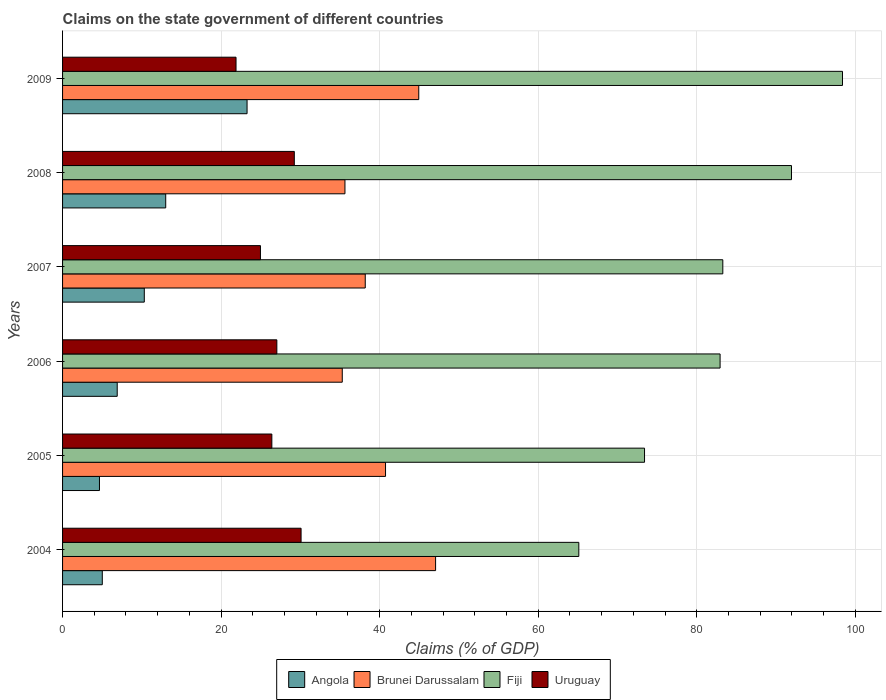How many different coloured bars are there?
Your answer should be compact. 4. How many groups of bars are there?
Make the answer very short. 6. How many bars are there on the 4th tick from the top?
Offer a terse response. 4. How many bars are there on the 5th tick from the bottom?
Offer a terse response. 4. What is the percentage of GDP claimed on the state government in Uruguay in 2004?
Provide a short and direct response. 30.08. Across all years, what is the maximum percentage of GDP claimed on the state government in Fiji?
Your answer should be compact. 98.38. Across all years, what is the minimum percentage of GDP claimed on the state government in Uruguay?
Offer a terse response. 21.88. In which year was the percentage of GDP claimed on the state government in Uruguay minimum?
Offer a terse response. 2009. What is the total percentage of GDP claimed on the state government in Brunei Darussalam in the graph?
Your answer should be compact. 241.79. What is the difference between the percentage of GDP claimed on the state government in Angola in 2006 and that in 2007?
Your answer should be compact. -3.42. What is the difference between the percentage of GDP claimed on the state government in Brunei Darussalam in 2009 and the percentage of GDP claimed on the state government in Fiji in 2007?
Keep it short and to the point. -38.35. What is the average percentage of GDP claimed on the state government in Uruguay per year?
Offer a very short reply. 26.6. In the year 2008, what is the difference between the percentage of GDP claimed on the state government in Fiji and percentage of GDP claimed on the state government in Uruguay?
Provide a succinct answer. 62.71. In how many years, is the percentage of GDP claimed on the state government in Angola greater than 4 %?
Offer a terse response. 6. What is the ratio of the percentage of GDP claimed on the state government in Fiji in 2006 to that in 2009?
Provide a succinct answer. 0.84. Is the percentage of GDP claimed on the state government in Brunei Darussalam in 2004 less than that in 2005?
Ensure brevity in your answer.  No. What is the difference between the highest and the second highest percentage of GDP claimed on the state government in Uruguay?
Make the answer very short. 0.85. What is the difference between the highest and the lowest percentage of GDP claimed on the state government in Brunei Darussalam?
Keep it short and to the point. 11.77. In how many years, is the percentage of GDP claimed on the state government in Uruguay greater than the average percentage of GDP claimed on the state government in Uruguay taken over all years?
Ensure brevity in your answer.  3. Is the sum of the percentage of GDP claimed on the state government in Fiji in 2006 and 2007 greater than the maximum percentage of GDP claimed on the state government in Brunei Darussalam across all years?
Keep it short and to the point. Yes. Is it the case that in every year, the sum of the percentage of GDP claimed on the state government in Brunei Darussalam and percentage of GDP claimed on the state government in Uruguay is greater than the sum of percentage of GDP claimed on the state government in Fiji and percentage of GDP claimed on the state government in Angola?
Your answer should be very brief. Yes. What does the 4th bar from the top in 2007 represents?
Offer a terse response. Angola. What does the 2nd bar from the bottom in 2008 represents?
Offer a terse response. Brunei Darussalam. Is it the case that in every year, the sum of the percentage of GDP claimed on the state government in Angola and percentage of GDP claimed on the state government in Fiji is greater than the percentage of GDP claimed on the state government in Brunei Darussalam?
Make the answer very short. Yes. How many bars are there?
Keep it short and to the point. 24. Are the values on the major ticks of X-axis written in scientific E-notation?
Your answer should be very brief. No. Does the graph contain grids?
Your answer should be compact. Yes. Where does the legend appear in the graph?
Provide a short and direct response. Bottom center. How many legend labels are there?
Provide a short and direct response. 4. How are the legend labels stacked?
Your answer should be compact. Horizontal. What is the title of the graph?
Offer a very short reply. Claims on the state government of different countries. Does "Turkmenistan" appear as one of the legend labels in the graph?
Keep it short and to the point. No. What is the label or title of the X-axis?
Your answer should be very brief. Claims (% of GDP). What is the label or title of the Y-axis?
Provide a short and direct response. Years. What is the Claims (% of GDP) in Angola in 2004?
Your answer should be very brief. 5.01. What is the Claims (% of GDP) of Brunei Darussalam in 2004?
Provide a succinct answer. 47.05. What is the Claims (% of GDP) in Fiji in 2004?
Ensure brevity in your answer.  65.12. What is the Claims (% of GDP) in Uruguay in 2004?
Your response must be concise. 30.08. What is the Claims (% of GDP) of Angola in 2005?
Your answer should be compact. 4.66. What is the Claims (% of GDP) in Brunei Darussalam in 2005?
Your answer should be very brief. 40.74. What is the Claims (% of GDP) of Fiji in 2005?
Offer a terse response. 73.4. What is the Claims (% of GDP) in Uruguay in 2005?
Your answer should be compact. 26.4. What is the Claims (% of GDP) in Angola in 2006?
Keep it short and to the point. 6.89. What is the Claims (% of GDP) of Brunei Darussalam in 2006?
Offer a terse response. 35.28. What is the Claims (% of GDP) of Fiji in 2006?
Provide a short and direct response. 82.94. What is the Claims (% of GDP) in Uruguay in 2006?
Offer a terse response. 27.03. What is the Claims (% of GDP) of Angola in 2007?
Offer a terse response. 10.31. What is the Claims (% of GDP) of Brunei Darussalam in 2007?
Ensure brevity in your answer.  38.18. What is the Claims (% of GDP) of Fiji in 2007?
Provide a succinct answer. 83.28. What is the Claims (% of GDP) of Uruguay in 2007?
Your response must be concise. 24.96. What is the Claims (% of GDP) in Angola in 2008?
Offer a very short reply. 13.01. What is the Claims (% of GDP) in Brunei Darussalam in 2008?
Your response must be concise. 35.62. What is the Claims (% of GDP) of Fiji in 2008?
Give a very brief answer. 91.94. What is the Claims (% of GDP) in Uruguay in 2008?
Provide a succinct answer. 29.23. What is the Claims (% of GDP) of Angola in 2009?
Give a very brief answer. 23.27. What is the Claims (% of GDP) of Brunei Darussalam in 2009?
Make the answer very short. 44.93. What is the Claims (% of GDP) of Fiji in 2009?
Provide a short and direct response. 98.38. What is the Claims (% of GDP) in Uruguay in 2009?
Ensure brevity in your answer.  21.88. Across all years, what is the maximum Claims (% of GDP) in Angola?
Offer a terse response. 23.27. Across all years, what is the maximum Claims (% of GDP) of Brunei Darussalam?
Your answer should be very brief. 47.05. Across all years, what is the maximum Claims (% of GDP) in Fiji?
Your answer should be compact. 98.38. Across all years, what is the maximum Claims (% of GDP) of Uruguay?
Your answer should be compact. 30.08. Across all years, what is the minimum Claims (% of GDP) in Angola?
Provide a succinct answer. 4.66. Across all years, what is the minimum Claims (% of GDP) of Brunei Darussalam?
Your answer should be compact. 35.28. Across all years, what is the minimum Claims (% of GDP) of Fiji?
Your response must be concise. 65.12. Across all years, what is the minimum Claims (% of GDP) of Uruguay?
Your answer should be very brief. 21.88. What is the total Claims (% of GDP) of Angola in the graph?
Ensure brevity in your answer.  63.15. What is the total Claims (% of GDP) of Brunei Darussalam in the graph?
Your answer should be compact. 241.79. What is the total Claims (% of GDP) in Fiji in the graph?
Make the answer very short. 495.05. What is the total Claims (% of GDP) of Uruguay in the graph?
Ensure brevity in your answer.  159.58. What is the difference between the Claims (% of GDP) in Angola in 2004 and that in 2005?
Your answer should be compact. 0.36. What is the difference between the Claims (% of GDP) in Brunei Darussalam in 2004 and that in 2005?
Your answer should be very brief. 6.31. What is the difference between the Claims (% of GDP) of Fiji in 2004 and that in 2005?
Provide a short and direct response. -8.29. What is the difference between the Claims (% of GDP) in Uruguay in 2004 and that in 2005?
Give a very brief answer. 3.69. What is the difference between the Claims (% of GDP) of Angola in 2004 and that in 2006?
Keep it short and to the point. -1.88. What is the difference between the Claims (% of GDP) of Brunei Darussalam in 2004 and that in 2006?
Keep it short and to the point. 11.77. What is the difference between the Claims (% of GDP) of Fiji in 2004 and that in 2006?
Provide a succinct answer. -17.82. What is the difference between the Claims (% of GDP) of Uruguay in 2004 and that in 2006?
Your answer should be very brief. 3.06. What is the difference between the Claims (% of GDP) in Angola in 2004 and that in 2007?
Provide a short and direct response. -5.3. What is the difference between the Claims (% of GDP) of Brunei Darussalam in 2004 and that in 2007?
Your answer should be compact. 8.87. What is the difference between the Claims (% of GDP) of Fiji in 2004 and that in 2007?
Ensure brevity in your answer.  -18.16. What is the difference between the Claims (% of GDP) of Uruguay in 2004 and that in 2007?
Your answer should be very brief. 5.12. What is the difference between the Claims (% of GDP) in Angola in 2004 and that in 2008?
Offer a terse response. -8. What is the difference between the Claims (% of GDP) of Brunei Darussalam in 2004 and that in 2008?
Make the answer very short. 11.43. What is the difference between the Claims (% of GDP) in Fiji in 2004 and that in 2008?
Your answer should be very brief. -26.83. What is the difference between the Claims (% of GDP) of Uruguay in 2004 and that in 2008?
Your answer should be very brief. 0.85. What is the difference between the Claims (% of GDP) in Angola in 2004 and that in 2009?
Provide a short and direct response. -18.26. What is the difference between the Claims (% of GDP) in Brunei Darussalam in 2004 and that in 2009?
Offer a terse response. 2.12. What is the difference between the Claims (% of GDP) of Fiji in 2004 and that in 2009?
Provide a succinct answer. -33.26. What is the difference between the Claims (% of GDP) in Uruguay in 2004 and that in 2009?
Offer a terse response. 8.2. What is the difference between the Claims (% of GDP) in Angola in 2005 and that in 2006?
Ensure brevity in your answer.  -2.24. What is the difference between the Claims (% of GDP) in Brunei Darussalam in 2005 and that in 2006?
Give a very brief answer. 5.46. What is the difference between the Claims (% of GDP) of Fiji in 2005 and that in 2006?
Your answer should be very brief. -9.53. What is the difference between the Claims (% of GDP) in Uruguay in 2005 and that in 2006?
Your answer should be very brief. -0.63. What is the difference between the Claims (% of GDP) in Angola in 2005 and that in 2007?
Make the answer very short. -5.65. What is the difference between the Claims (% of GDP) in Brunei Darussalam in 2005 and that in 2007?
Your answer should be very brief. 2.56. What is the difference between the Claims (% of GDP) in Fiji in 2005 and that in 2007?
Give a very brief answer. -9.87. What is the difference between the Claims (% of GDP) of Uruguay in 2005 and that in 2007?
Provide a short and direct response. 1.44. What is the difference between the Claims (% of GDP) of Angola in 2005 and that in 2008?
Offer a terse response. -8.36. What is the difference between the Claims (% of GDP) in Brunei Darussalam in 2005 and that in 2008?
Your answer should be very brief. 5.12. What is the difference between the Claims (% of GDP) in Fiji in 2005 and that in 2008?
Give a very brief answer. -18.54. What is the difference between the Claims (% of GDP) of Uruguay in 2005 and that in 2008?
Offer a very short reply. -2.83. What is the difference between the Claims (% of GDP) of Angola in 2005 and that in 2009?
Make the answer very short. -18.62. What is the difference between the Claims (% of GDP) in Brunei Darussalam in 2005 and that in 2009?
Provide a succinct answer. -4.19. What is the difference between the Claims (% of GDP) of Fiji in 2005 and that in 2009?
Keep it short and to the point. -24.97. What is the difference between the Claims (% of GDP) in Uruguay in 2005 and that in 2009?
Provide a succinct answer. 4.52. What is the difference between the Claims (% of GDP) of Angola in 2006 and that in 2007?
Ensure brevity in your answer.  -3.42. What is the difference between the Claims (% of GDP) of Fiji in 2006 and that in 2007?
Offer a very short reply. -0.34. What is the difference between the Claims (% of GDP) in Uruguay in 2006 and that in 2007?
Offer a very short reply. 2.07. What is the difference between the Claims (% of GDP) in Angola in 2006 and that in 2008?
Provide a short and direct response. -6.12. What is the difference between the Claims (% of GDP) in Brunei Darussalam in 2006 and that in 2008?
Your answer should be very brief. -0.34. What is the difference between the Claims (% of GDP) in Fiji in 2006 and that in 2008?
Provide a succinct answer. -9. What is the difference between the Claims (% of GDP) of Uruguay in 2006 and that in 2008?
Give a very brief answer. -2.2. What is the difference between the Claims (% of GDP) in Angola in 2006 and that in 2009?
Keep it short and to the point. -16.38. What is the difference between the Claims (% of GDP) of Brunei Darussalam in 2006 and that in 2009?
Ensure brevity in your answer.  -9.65. What is the difference between the Claims (% of GDP) in Fiji in 2006 and that in 2009?
Offer a very short reply. -15.44. What is the difference between the Claims (% of GDP) in Uruguay in 2006 and that in 2009?
Provide a short and direct response. 5.15. What is the difference between the Claims (% of GDP) of Angola in 2007 and that in 2008?
Give a very brief answer. -2.7. What is the difference between the Claims (% of GDP) in Brunei Darussalam in 2007 and that in 2008?
Offer a very short reply. 2.56. What is the difference between the Claims (% of GDP) in Fiji in 2007 and that in 2008?
Give a very brief answer. -8.66. What is the difference between the Claims (% of GDP) of Uruguay in 2007 and that in 2008?
Provide a succinct answer. -4.27. What is the difference between the Claims (% of GDP) in Angola in 2007 and that in 2009?
Your answer should be compact. -12.96. What is the difference between the Claims (% of GDP) in Brunei Darussalam in 2007 and that in 2009?
Offer a very short reply. -6.75. What is the difference between the Claims (% of GDP) in Fiji in 2007 and that in 2009?
Ensure brevity in your answer.  -15.1. What is the difference between the Claims (% of GDP) in Uruguay in 2007 and that in 2009?
Give a very brief answer. 3.08. What is the difference between the Claims (% of GDP) in Angola in 2008 and that in 2009?
Make the answer very short. -10.26. What is the difference between the Claims (% of GDP) in Brunei Darussalam in 2008 and that in 2009?
Make the answer very short. -9.31. What is the difference between the Claims (% of GDP) in Fiji in 2008 and that in 2009?
Keep it short and to the point. -6.43. What is the difference between the Claims (% of GDP) in Uruguay in 2008 and that in 2009?
Offer a very short reply. 7.35. What is the difference between the Claims (% of GDP) in Angola in 2004 and the Claims (% of GDP) in Brunei Darussalam in 2005?
Make the answer very short. -35.73. What is the difference between the Claims (% of GDP) in Angola in 2004 and the Claims (% of GDP) in Fiji in 2005?
Your answer should be compact. -68.39. What is the difference between the Claims (% of GDP) of Angola in 2004 and the Claims (% of GDP) of Uruguay in 2005?
Offer a very short reply. -21.39. What is the difference between the Claims (% of GDP) of Brunei Darussalam in 2004 and the Claims (% of GDP) of Fiji in 2005?
Your answer should be compact. -26.35. What is the difference between the Claims (% of GDP) in Brunei Darussalam in 2004 and the Claims (% of GDP) in Uruguay in 2005?
Ensure brevity in your answer.  20.65. What is the difference between the Claims (% of GDP) of Fiji in 2004 and the Claims (% of GDP) of Uruguay in 2005?
Offer a very short reply. 38.72. What is the difference between the Claims (% of GDP) in Angola in 2004 and the Claims (% of GDP) in Brunei Darussalam in 2006?
Your answer should be very brief. -30.27. What is the difference between the Claims (% of GDP) of Angola in 2004 and the Claims (% of GDP) of Fiji in 2006?
Offer a very short reply. -77.92. What is the difference between the Claims (% of GDP) in Angola in 2004 and the Claims (% of GDP) in Uruguay in 2006?
Your response must be concise. -22.02. What is the difference between the Claims (% of GDP) in Brunei Darussalam in 2004 and the Claims (% of GDP) in Fiji in 2006?
Offer a terse response. -35.89. What is the difference between the Claims (% of GDP) in Brunei Darussalam in 2004 and the Claims (% of GDP) in Uruguay in 2006?
Offer a terse response. 20.02. What is the difference between the Claims (% of GDP) in Fiji in 2004 and the Claims (% of GDP) in Uruguay in 2006?
Offer a terse response. 38.09. What is the difference between the Claims (% of GDP) in Angola in 2004 and the Claims (% of GDP) in Brunei Darussalam in 2007?
Provide a short and direct response. -33.17. What is the difference between the Claims (% of GDP) of Angola in 2004 and the Claims (% of GDP) of Fiji in 2007?
Make the answer very short. -78.27. What is the difference between the Claims (% of GDP) in Angola in 2004 and the Claims (% of GDP) in Uruguay in 2007?
Offer a terse response. -19.95. What is the difference between the Claims (% of GDP) of Brunei Darussalam in 2004 and the Claims (% of GDP) of Fiji in 2007?
Offer a very short reply. -36.23. What is the difference between the Claims (% of GDP) of Brunei Darussalam in 2004 and the Claims (% of GDP) of Uruguay in 2007?
Provide a short and direct response. 22.09. What is the difference between the Claims (% of GDP) in Fiji in 2004 and the Claims (% of GDP) in Uruguay in 2007?
Provide a short and direct response. 40.16. What is the difference between the Claims (% of GDP) in Angola in 2004 and the Claims (% of GDP) in Brunei Darussalam in 2008?
Keep it short and to the point. -30.61. What is the difference between the Claims (% of GDP) in Angola in 2004 and the Claims (% of GDP) in Fiji in 2008?
Your answer should be compact. -86.93. What is the difference between the Claims (% of GDP) of Angola in 2004 and the Claims (% of GDP) of Uruguay in 2008?
Provide a succinct answer. -24.22. What is the difference between the Claims (% of GDP) of Brunei Darussalam in 2004 and the Claims (% of GDP) of Fiji in 2008?
Offer a very short reply. -44.89. What is the difference between the Claims (% of GDP) of Brunei Darussalam in 2004 and the Claims (% of GDP) of Uruguay in 2008?
Keep it short and to the point. 17.82. What is the difference between the Claims (% of GDP) of Fiji in 2004 and the Claims (% of GDP) of Uruguay in 2008?
Make the answer very short. 35.89. What is the difference between the Claims (% of GDP) in Angola in 2004 and the Claims (% of GDP) in Brunei Darussalam in 2009?
Keep it short and to the point. -39.92. What is the difference between the Claims (% of GDP) in Angola in 2004 and the Claims (% of GDP) in Fiji in 2009?
Offer a terse response. -93.36. What is the difference between the Claims (% of GDP) in Angola in 2004 and the Claims (% of GDP) in Uruguay in 2009?
Your answer should be very brief. -16.87. What is the difference between the Claims (% of GDP) of Brunei Darussalam in 2004 and the Claims (% of GDP) of Fiji in 2009?
Your answer should be compact. -51.32. What is the difference between the Claims (% of GDP) of Brunei Darussalam in 2004 and the Claims (% of GDP) of Uruguay in 2009?
Offer a terse response. 25.17. What is the difference between the Claims (% of GDP) of Fiji in 2004 and the Claims (% of GDP) of Uruguay in 2009?
Ensure brevity in your answer.  43.24. What is the difference between the Claims (% of GDP) of Angola in 2005 and the Claims (% of GDP) of Brunei Darussalam in 2006?
Your response must be concise. -30.62. What is the difference between the Claims (% of GDP) in Angola in 2005 and the Claims (% of GDP) in Fiji in 2006?
Provide a short and direct response. -78.28. What is the difference between the Claims (% of GDP) of Angola in 2005 and the Claims (% of GDP) of Uruguay in 2006?
Make the answer very short. -22.37. What is the difference between the Claims (% of GDP) in Brunei Darussalam in 2005 and the Claims (% of GDP) in Fiji in 2006?
Provide a short and direct response. -42.2. What is the difference between the Claims (% of GDP) in Brunei Darussalam in 2005 and the Claims (% of GDP) in Uruguay in 2006?
Your response must be concise. 13.71. What is the difference between the Claims (% of GDP) in Fiji in 2005 and the Claims (% of GDP) in Uruguay in 2006?
Provide a short and direct response. 46.38. What is the difference between the Claims (% of GDP) in Angola in 2005 and the Claims (% of GDP) in Brunei Darussalam in 2007?
Your answer should be very brief. -33.52. What is the difference between the Claims (% of GDP) in Angola in 2005 and the Claims (% of GDP) in Fiji in 2007?
Make the answer very short. -78.62. What is the difference between the Claims (% of GDP) of Angola in 2005 and the Claims (% of GDP) of Uruguay in 2007?
Provide a short and direct response. -20.3. What is the difference between the Claims (% of GDP) in Brunei Darussalam in 2005 and the Claims (% of GDP) in Fiji in 2007?
Provide a short and direct response. -42.54. What is the difference between the Claims (% of GDP) of Brunei Darussalam in 2005 and the Claims (% of GDP) of Uruguay in 2007?
Offer a terse response. 15.78. What is the difference between the Claims (% of GDP) in Fiji in 2005 and the Claims (% of GDP) in Uruguay in 2007?
Your answer should be compact. 48.45. What is the difference between the Claims (% of GDP) in Angola in 2005 and the Claims (% of GDP) in Brunei Darussalam in 2008?
Your response must be concise. -30.96. What is the difference between the Claims (% of GDP) in Angola in 2005 and the Claims (% of GDP) in Fiji in 2008?
Provide a short and direct response. -87.29. What is the difference between the Claims (% of GDP) in Angola in 2005 and the Claims (% of GDP) in Uruguay in 2008?
Your response must be concise. -24.57. What is the difference between the Claims (% of GDP) in Brunei Darussalam in 2005 and the Claims (% of GDP) in Fiji in 2008?
Provide a short and direct response. -51.2. What is the difference between the Claims (% of GDP) of Brunei Darussalam in 2005 and the Claims (% of GDP) of Uruguay in 2008?
Your answer should be very brief. 11.51. What is the difference between the Claims (% of GDP) in Fiji in 2005 and the Claims (% of GDP) in Uruguay in 2008?
Make the answer very short. 44.17. What is the difference between the Claims (% of GDP) in Angola in 2005 and the Claims (% of GDP) in Brunei Darussalam in 2009?
Your answer should be very brief. -40.27. What is the difference between the Claims (% of GDP) of Angola in 2005 and the Claims (% of GDP) of Fiji in 2009?
Your answer should be very brief. -93.72. What is the difference between the Claims (% of GDP) in Angola in 2005 and the Claims (% of GDP) in Uruguay in 2009?
Provide a succinct answer. -17.22. What is the difference between the Claims (% of GDP) in Brunei Darussalam in 2005 and the Claims (% of GDP) in Fiji in 2009?
Provide a succinct answer. -57.64. What is the difference between the Claims (% of GDP) of Brunei Darussalam in 2005 and the Claims (% of GDP) of Uruguay in 2009?
Ensure brevity in your answer.  18.86. What is the difference between the Claims (% of GDP) in Fiji in 2005 and the Claims (% of GDP) in Uruguay in 2009?
Keep it short and to the point. 51.53. What is the difference between the Claims (% of GDP) in Angola in 2006 and the Claims (% of GDP) in Brunei Darussalam in 2007?
Your answer should be compact. -31.28. What is the difference between the Claims (% of GDP) of Angola in 2006 and the Claims (% of GDP) of Fiji in 2007?
Ensure brevity in your answer.  -76.38. What is the difference between the Claims (% of GDP) of Angola in 2006 and the Claims (% of GDP) of Uruguay in 2007?
Your answer should be very brief. -18.07. What is the difference between the Claims (% of GDP) of Brunei Darussalam in 2006 and the Claims (% of GDP) of Fiji in 2007?
Ensure brevity in your answer.  -48. What is the difference between the Claims (% of GDP) of Brunei Darussalam in 2006 and the Claims (% of GDP) of Uruguay in 2007?
Provide a succinct answer. 10.32. What is the difference between the Claims (% of GDP) in Fiji in 2006 and the Claims (% of GDP) in Uruguay in 2007?
Give a very brief answer. 57.98. What is the difference between the Claims (% of GDP) in Angola in 2006 and the Claims (% of GDP) in Brunei Darussalam in 2008?
Offer a terse response. -28.72. What is the difference between the Claims (% of GDP) in Angola in 2006 and the Claims (% of GDP) in Fiji in 2008?
Provide a short and direct response. -85.05. What is the difference between the Claims (% of GDP) in Angola in 2006 and the Claims (% of GDP) in Uruguay in 2008?
Provide a succinct answer. -22.34. What is the difference between the Claims (% of GDP) in Brunei Darussalam in 2006 and the Claims (% of GDP) in Fiji in 2008?
Provide a short and direct response. -56.66. What is the difference between the Claims (% of GDP) in Brunei Darussalam in 2006 and the Claims (% of GDP) in Uruguay in 2008?
Keep it short and to the point. 6.05. What is the difference between the Claims (% of GDP) of Fiji in 2006 and the Claims (% of GDP) of Uruguay in 2008?
Provide a succinct answer. 53.71. What is the difference between the Claims (% of GDP) of Angola in 2006 and the Claims (% of GDP) of Brunei Darussalam in 2009?
Give a very brief answer. -38.04. What is the difference between the Claims (% of GDP) in Angola in 2006 and the Claims (% of GDP) in Fiji in 2009?
Keep it short and to the point. -91.48. What is the difference between the Claims (% of GDP) of Angola in 2006 and the Claims (% of GDP) of Uruguay in 2009?
Your answer should be very brief. -14.99. What is the difference between the Claims (% of GDP) of Brunei Darussalam in 2006 and the Claims (% of GDP) of Fiji in 2009?
Keep it short and to the point. -63.1. What is the difference between the Claims (% of GDP) in Brunei Darussalam in 2006 and the Claims (% of GDP) in Uruguay in 2009?
Offer a very short reply. 13.4. What is the difference between the Claims (% of GDP) in Fiji in 2006 and the Claims (% of GDP) in Uruguay in 2009?
Provide a succinct answer. 61.06. What is the difference between the Claims (% of GDP) of Angola in 2007 and the Claims (% of GDP) of Brunei Darussalam in 2008?
Keep it short and to the point. -25.31. What is the difference between the Claims (% of GDP) of Angola in 2007 and the Claims (% of GDP) of Fiji in 2008?
Your answer should be very brief. -81.63. What is the difference between the Claims (% of GDP) of Angola in 2007 and the Claims (% of GDP) of Uruguay in 2008?
Give a very brief answer. -18.92. What is the difference between the Claims (% of GDP) of Brunei Darussalam in 2007 and the Claims (% of GDP) of Fiji in 2008?
Your response must be concise. -53.76. What is the difference between the Claims (% of GDP) of Brunei Darussalam in 2007 and the Claims (% of GDP) of Uruguay in 2008?
Your response must be concise. 8.95. What is the difference between the Claims (% of GDP) of Fiji in 2007 and the Claims (% of GDP) of Uruguay in 2008?
Give a very brief answer. 54.05. What is the difference between the Claims (% of GDP) of Angola in 2007 and the Claims (% of GDP) of Brunei Darussalam in 2009?
Make the answer very short. -34.62. What is the difference between the Claims (% of GDP) of Angola in 2007 and the Claims (% of GDP) of Fiji in 2009?
Ensure brevity in your answer.  -88.07. What is the difference between the Claims (% of GDP) in Angola in 2007 and the Claims (% of GDP) in Uruguay in 2009?
Provide a succinct answer. -11.57. What is the difference between the Claims (% of GDP) of Brunei Darussalam in 2007 and the Claims (% of GDP) of Fiji in 2009?
Make the answer very short. -60.2. What is the difference between the Claims (% of GDP) in Brunei Darussalam in 2007 and the Claims (% of GDP) in Uruguay in 2009?
Your response must be concise. 16.3. What is the difference between the Claims (% of GDP) of Fiji in 2007 and the Claims (% of GDP) of Uruguay in 2009?
Make the answer very short. 61.4. What is the difference between the Claims (% of GDP) in Angola in 2008 and the Claims (% of GDP) in Brunei Darussalam in 2009?
Give a very brief answer. -31.92. What is the difference between the Claims (% of GDP) in Angola in 2008 and the Claims (% of GDP) in Fiji in 2009?
Your answer should be very brief. -85.36. What is the difference between the Claims (% of GDP) in Angola in 2008 and the Claims (% of GDP) in Uruguay in 2009?
Ensure brevity in your answer.  -8.87. What is the difference between the Claims (% of GDP) in Brunei Darussalam in 2008 and the Claims (% of GDP) in Fiji in 2009?
Your response must be concise. -62.76. What is the difference between the Claims (% of GDP) of Brunei Darussalam in 2008 and the Claims (% of GDP) of Uruguay in 2009?
Your answer should be very brief. 13.74. What is the difference between the Claims (% of GDP) of Fiji in 2008 and the Claims (% of GDP) of Uruguay in 2009?
Offer a very short reply. 70.06. What is the average Claims (% of GDP) in Angola per year?
Provide a short and direct response. 10.53. What is the average Claims (% of GDP) in Brunei Darussalam per year?
Give a very brief answer. 40.3. What is the average Claims (% of GDP) in Fiji per year?
Provide a short and direct response. 82.51. What is the average Claims (% of GDP) of Uruguay per year?
Ensure brevity in your answer.  26.6. In the year 2004, what is the difference between the Claims (% of GDP) in Angola and Claims (% of GDP) in Brunei Darussalam?
Your response must be concise. -42.04. In the year 2004, what is the difference between the Claims (% of GDP) of Angola and Claims (% of GDP) of Fiji?
Offer a terse response. -60.1. In the year 2004, what is the difference between the Claims (% of GDP) in Angola and Claims (% of GDP) in Uruguay?
Ensure brevity in your answer.  -25.07. In the year 2004, what is the difference between the Claims (% of GDP) of Brunei Darussalam and Claims (% of GDP) of Fiji?
Provide a short and direct response. -18.06. In the year 2004, what is the difference between the Claims (% of GDP) of Brunei Darussalam and Claims (% of GDP) of Uruguay?
Your answer should be very brief. 16.97. In the year 2004, what is the difference between the Claims (% of GDP) of Fiji and Claims (% of GDP) of Uruguay?
Make the answer very short. 35.03. In the year 2005, what is the difference between the Claims (% of GDP) in Angola and Claims (% of GDP) in Brunei Darussalam?
Make the answer very short. -36.08. In the year 2005, what is the difference between the Claims (% of GDP) in Angola and Claims (% of GDP) in Fiji?
Your response must be concise. -68.75. In the year 2005, what is the difference between the Claims (% of GDP) in Angola and Claims (% of GDP) in Uruguay?
Offer a terse response. -21.74. In the year 2005, what is the difference between the Claims (% of GDP) in Brunei Darussalam and Claims (% of GDP) in Fiji?
Provide a succinct answer. -32.67. In the year 2005, what is the difference between the Claims (% of GDP) of Brunei Darussalam and Claims (% of GDP) of Uruguay?
Give a very brief answer. 14.34. In the year 2005, what is the difference between the Claims (% of GDP) in Fiji and Claims (% of GDP) in Uruguay?
Ensure brevity in your answer.  47.01. In the year 2006, what is the difference between the Claims (% of GDP) in Angola and Claims (% of GDP) in Brunei Darussalam?
Your answer should be very brief. -28.38. In the year 2006, what is the difference between the Claims (% of GDP) in Angola and Claims (% of GDP) in Fiji?
Make the answer very short. -76.04. In the year 2006, what is the difference between the Claims (% of GDP) in Angola and Claims (% of GDP) in Uruguay?
Keep it short and to the point. -20.13. In the year 2006, what is the difference between the Claims (% of GDP) in Brunei Darussalam and Claims (% of GDP) in Fiji?
Your answer should be compact. -47.66. In the year 2006, what is the difference between the Claims (% of GDP) in Brunei Darussalam and Claims (% of GDP) in Uruguay?
Your response must be concise. 8.25. In the year 2006, what is the difference between the Claims (% of GDP) of Fiji and Claims (% of GDP) of Uruguay?
Ensure brevity in your answer.  55.91. In the year 2007, what is the difference between the Claims (% of GDP) of Angola and Claims (% of GDP) of Brunei Darussalam?
Give a very brief answer. -27.87. In the year 2007, what is the difference between the Claims (% of GDP) in Angola and Claims (% of GDP) in Fiji?
Offer a very short reply. -72.97. In the year 2007, what is the difference between the Claims (% of GDP) of Angola and Claims (% of GDP) of Uruguay?
Make the answer very short. -14.65. In the year 2007, what is the difference between the Claims (% of GDP) of Brunei Darussalam and Claims (% of GDP) of Fiji?
Offer a terse response. -45.1. In the year 2007, what is the difference between the Claims (% of GDP) of Brunei Darussalam and Claims (% of GDP) of Uruguay?
Keep it short and to the point. 13.22. In the year 2007, what is the difference between the Claims (% of GDP) in Fiji and Claims (% of GDP) in Uruguay?
Your answer should be very brief. 58.32. In the year 2008, what is the difference between the Claims (% of GDP) in Angola and Claims (% of GDP) in Brunei Darussalam?
Give a very brief answer. -22.61. In the year 2008, what is the difference between the Claims (% of GDP) of Angola and Claims (% of GDP) of Fiji?
Ensure brevity in your answer.  -78.93. In the year 2008, what is the difference between the Claims (% of GDP) of Angola and Claims (% of GDP) of Uruguay?
Provide a succinct answer. -16.22. In the year 2008, what is the difference between the Claims (% of GDP) in Brunei Darussalam and Claims (% of GDP) in Fiji?
Keep it short and to the point. -56.32. In the year 2008, what is the difference between the Claims (% of GDP) in Brunei Darussalam and Claims (% of GDP) in Uruguay?
Provide a short and direct response. 6.39. In the year 2008, what is the difference between the Claims (% of GDP) of Fiji and Claims (% of GDP) of Uruguay?
Provide a short and direct response. 62.71. In the year 2009, what is the difference between the Claims (% of GDP) of Angola and Claims (% of GDP) of Brunei Darussalam?
Your answer should be compact. -21.66. In the year 2009, what is the difference between the Claims (% of GDP) in Angola and Claims (% of GDP) in Fiji?
Provide a short and direct response. -75.1. In the year 2009, what is the difference between the Claims (% of GDP) in Angola and Claims (% of GDP) in Uruguay?
Provide a short and direct response. 1.39. In the year 2009, what is the difference between the Claims (% of GDP) of Brunei Darussalam and Claims (% of GDP) of Fiji?
Make the answer very short. -53.45. In the year 2009, what is the difference between the Claims (% of GDP) of Brunei Darussalam and Claims (% of GDP) of Uruguay?
Provide a succinct answer. 23.05. In the year 2009, what is the difference between the Claims (% of GDP) of Fiji and Claims (% of GDP) of Uruguay?
Your response must be concise. 76.5. What is the ratio of the Claims (% of GDP) in Angola in 2004 to that in 2005?
Provide a succinct answer. 1.08. What is the ratio of the Claims (% of GDP) of Brunei Darussalam in 2004 to that in 2005?
Offer a very short reply. 1.16. What is the ratio of the Claims (% of GDP) of Fiji in 2004 to that in 2005?
Your response must be concise. 0.89. What is the ratio of the Claims (% of GDP) of Uruguay in 2004 to that in 2005?
Give a very brief answer. 1.14. What is the ratio of the Claims (% of GDP) of Angola in 2004 to that in 2006?
Offer a very short reply. 0.73. What is the ratio of the Claims (% of GDP) of Brunei Darussalam in 2004 to that in 2006?
Your response must be concise. 1.33. What is the ratio of the Claims (% of GDP) of Fiji in 2004 to that in 2006?
Ensure brevity in your answer.  0.79. What is the ratio of the Claims (% of GDP) in Uruguay in 2004 to that in 2006?
Keep it short and to the point. 1.11. What is the ratio of the Claims (% of GDP) of Angola in 2004 to that in 2007?
Offer a terse response. 0.49. What is the ratio of the Claims (% of GDP) in Brunei Darussalam in 2004 to that in 2007?
Your response must be concise. 1.23. What is the ratio of the Claims (% of GDP) in Fiji in 2004 to that in 2007?
Your response must be concise. 0.78. What is the ratio of the Claims (% of GDP) of Uruguay in 2004 to that in 2007?
Offer a terse response. 1.21. What is the ratio of the Claims (% of GDP) in Angola in 2004 to that in 2008?
Give a very brief answer. 0.39. What is the ratio of the Claims (% of GDP) in Brunei Darussalam in 2004 to that in 2008?
Keep it short and to the point. 1.32. What is the ratio of the Claims (% of GDP) of Fiji in 2004 to that in 2008?
Offer a very short reply. 0.71. What is the ratio of the Claims (% of GDP) in Uruguay in 2004 to that in 2008?
Provide a short and direct response. 1.03. What is the ratio of the Claims (% of GDP) in Angola in 2004 to that in 2009?
Ensure brevity in your answer.  0.22. What is the ratio of the Claims (% of GDP) in Brunei Darussalam in 2004 to that in 2009?
Offer a very short reply. 1.05. What is the ratio of the Claims (% of GDP) of Fiji in 2004 to that in 2009?
Offer a terse response. 0.66. What is the ratio of the Claims (% of GDP) of Uruguay in 2004 to that in 2009?
Make the answer very short. 1.38. What is the ratio of the Claims (% of GDP) of Angola in 2005 to that in 2006?
Ensure brevity in your answer.  0.68. What is the ratio of the Claims (% of GDP) in Brunei Darussalam in 2005 to that in 2006?
Ensure brevity in your answer.  1.15. What is the ratio of the Claims (% of GDP) in Fiji in 2005 to that in 2006?
Keep it short and to the point. 0.89. What is the ratio of the Claims (% of GDP) in Uruguay in 2005 to that in 2006?
Offer a very short reply. 0.98. What is the ratio of the Claims (% of GDP) of Angola in 2005 to that in 2007?
Your answer should be very brief. 0.45. What is the ratio of the Claims (% of GDP) of Brunei Darussalam in 2005 to that in 2007?
Offer a terse response. 1.07. What is the ratio of the Claims (% of GDP) of Fiji in 2005 to that in 2007?
Your answer should be compact. 0.88. What is the ratio of the Claims (% of GDP) in Uruguay in 2005 to that in 2007?
Your answer should be compact. 1.06. What is the ratio of the Claims (% of GDP) in Angola in 2005 to that in 2008?
Your response must be concise. 0.36. What is the ratio of the Claims (% of GDP) in Brunei Darussalam in 2005 to that in 2008?
Make the answer very short. 1.14. What is the ratio of the Claims (% of GDP) of Fiji in 2005 to that in 2008?
Make the answer very short. 0.8. What is the ratio of the Claims (% of GDP) of Uruguay in 2005 to that in 2008?
Provide a short and direct response. 0.9. What is the ratio of the Claims (% of GDP) of Angola in 2005 to that in 2009?
Keep it short and to the point. 0.2. What is the ratio of the Claims (% of GDP) in Brunei Darussalam in 2005 to that in 2009?
Give a very brief answer. 0.91. What is the ratio of the Claims (% of GDP) of Fiji in 2005 to that in 2009?
Ensure brevity in your answer.  0.75. What is the ratio of the Claims (% of GDP) of Uruguay in 2005 to that in 2009?
Your answer should be very brief. 1.21. What is the ratio of the Claims (% of GDP) of Angola in 2006 to that in 2007?
Ensure brevity in your answer.  0.67. What is the ratio of the Claims (% of GDP) in Brunei Darussalam in 2006 to that in 2007?
Your answer should be compact. 0.92. What is the ratio of the Claims (% of GDP) in Uruguay in 2006 to that in 2007?
Provide a short and direct response. 1.08. What is the ratio of the Claims (% of GDP) in Angola in 2006 to that in 2008?
Your response must be concise. 0.53. What is the ratio of the Claims (% of GDP) in Fiji in 2006 to that in 2008?
Your answer should be compact. 0.9. What is the ratio of the Claims (% of GDP) in Uruguay in 2006 to that in 2008?
Your answer should be compact. 0.92. What is the ratio of the Claims (% of GDP) of Angola in 2006 to that in 2009?
Provide a short and direct response. 0.3. What is the ratio of the Claims (% of GDP) in Brunei Darussalam in 2006 to that in 2009?
Provide a succinct answer. 0.79. What is the ratio of the Claims (% of GDP) of Fiji in 2006 to that in 2009?
Keep it short and to the point. 0.84. What is the ratio of the Claims (% of GDP) of Uruguay in 2006 to that in 2009?
Your answer should be compact. 1.24. What is the ratio of the Claims (% of GDP) in Angola in 2007 to that in 2008?
Offer a very short reply. 0.79. What is the ratio of the Claims (% of GDP) in Brunei Darussalam in 2007 to that in 2008?
Offer a terse response. 1.07. What is the ratio of the Claims (% of GDP) in Fiji in 2007 to that in 2008?
Your answer should be compact. 0.91. What is the ratio of the Claims (% of GDP) of Uruguay in 2007 to that in 2008?
Provide a succinct answer. 0.85. What is the ratio of the Claims (% of GDP) of Angola in 2007 to that in 2009?
Provide a succinct answer. 0.44. What is the ratio of the Claims (% of GDP) of Brunei Darussalam in 2007 to that in 2009?
Offer a very short reply. 0.85. What is the ratio of the Claims (% of GDP) in Fiji in 2007 to that in 2009?
Offer a very short reply. 0.85. What is the ratio of the Claims (% of GDP) in Uruguay in 2007 to that in 2009?
Your answer should be very brief. 1.14. What is the ratio of the Claims (% of GDP) in Angola in 2008 to that in 2009?
Your response must be concise. 0.56. What is the ratio of the Claims (% of GDP) in Brunei Darussalam in 2008 to that in 2009?
Your answer should be very brief. 0.79. What is the ratio of the Claims (% of GDP) of Fiji in 2008 to that in 2009?
Offer a terse response. 0.93. What is the ratio of the Claims (% of GDP) of Uruguay in 2008 to that in 2009?
Your response must be concise. 1.34. What is the difference between the highest and the second highest Claims (% of GDP) in Angola?
Offer a terse response. 10.26. What is the difference between the highest and the second highest Claims (% of GDP) of Brunei Darussalam?
Your answer should be very brief. 2.12. What is the difference between the highest and the second highest Claims (% of GDP) of Fiji?
Ensure brevity in your answer.  6.43. What is the difference between the highest and the second highest Claims (% of GDP) in Uruguay?
Make the answer very short. 0.85. What is the difference between the highest and the lowest Claims (% of GDP) of Angola?
Keep it short and to the point. 18.62. What is the difference between the highest and the lowest Claims (% of GDP) of Brunei Darussalam?
Keep it short and to the point. 11.77. What is the difference between the highest and the lowest Claims (% of GDP) of Fiji?
Keep it short and to the point. 33.26. What is the difference between the highest and the lowest Claims (% of GDP) in Uruguay?
Offer a very short reply. 8.2. 